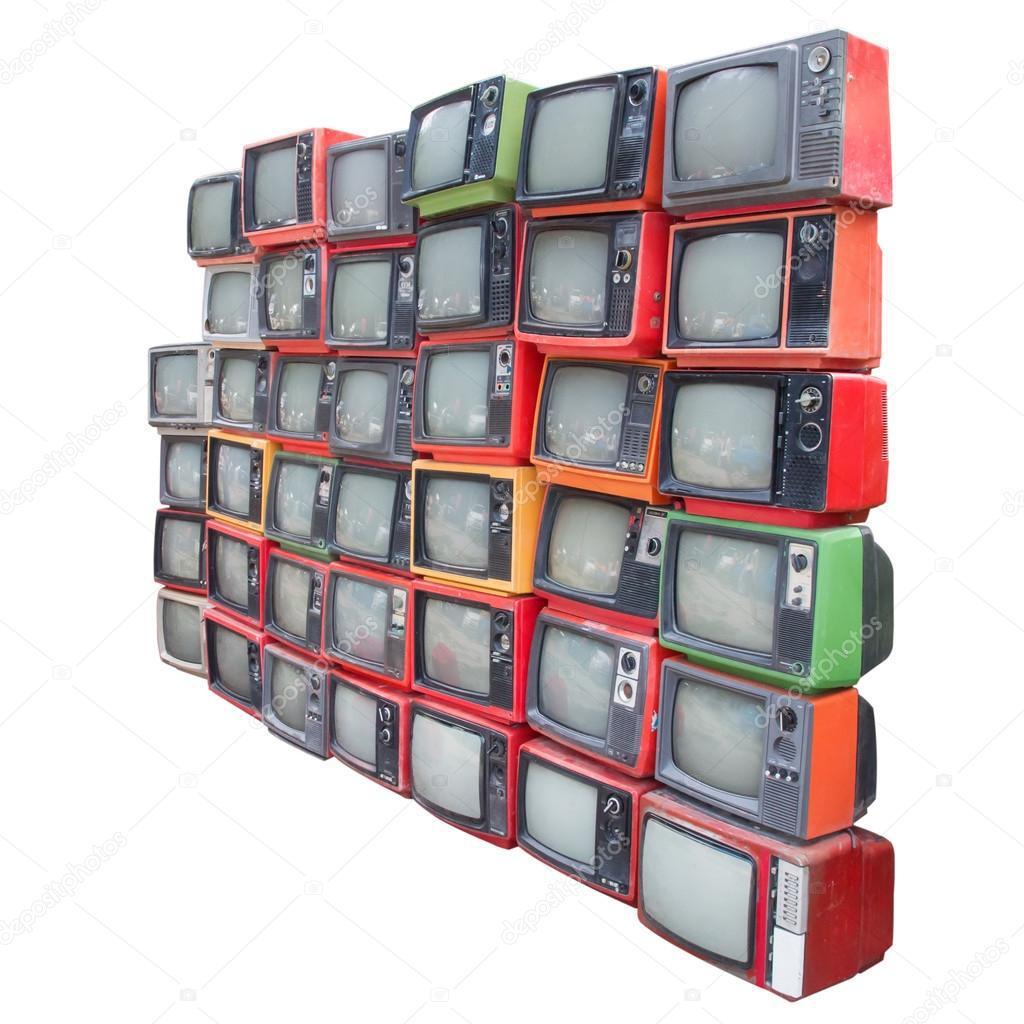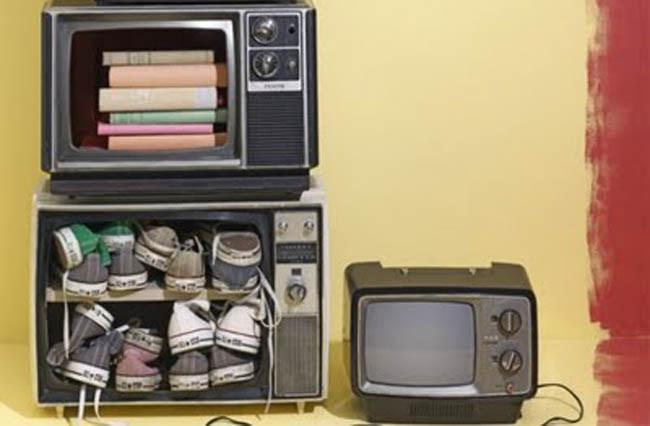The first image is the image on the left, the second image is the image on the right. Analyze the images presented: Is the assertion "Multiple colorful tv's are stacked on each other" valid? Answer yes or no. Yes. The first image is the image on the left, the second image is the image on the right. Evaluate the accuracy of this statement regarding the images: "In one of the images, there is only one television.". Is it true? Answer yes or no. No. 